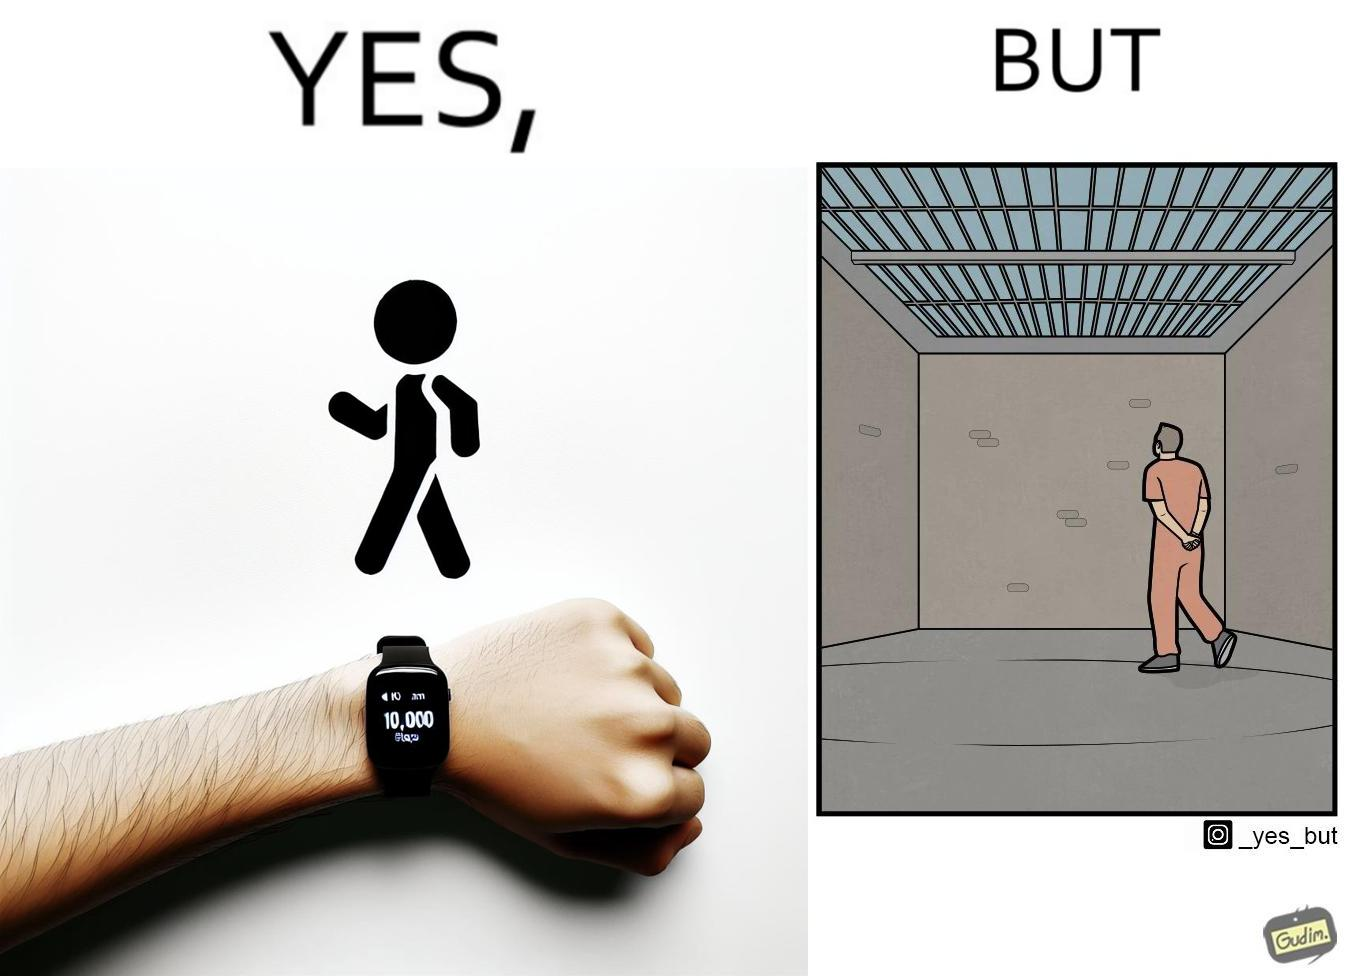Is there satirical content in this image? Yes, this image is satirical. 